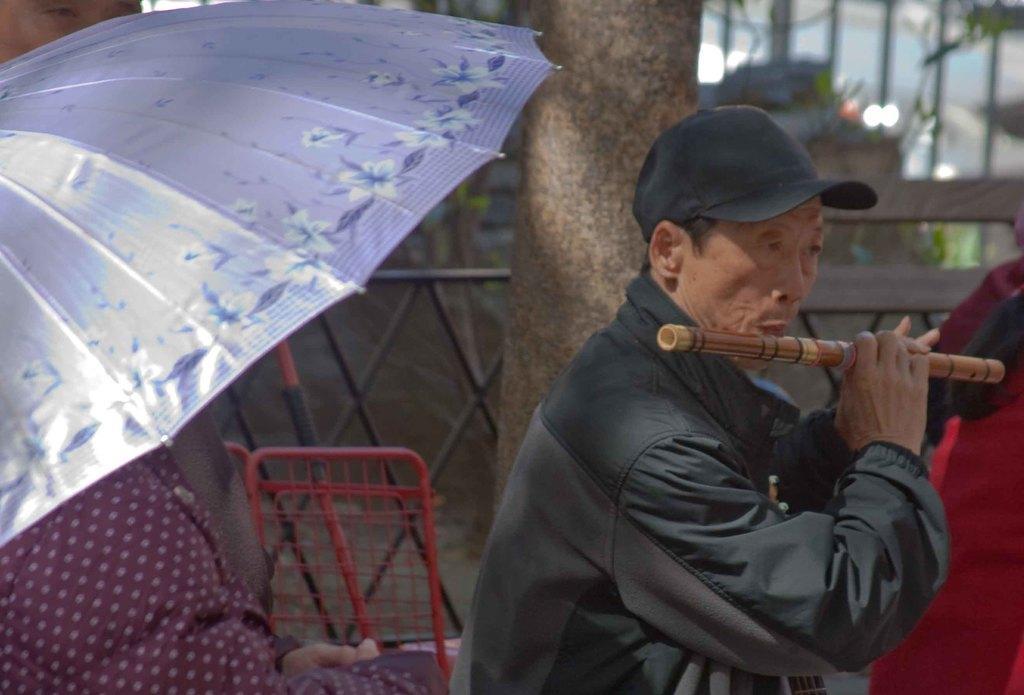Can you describe this image briefly? In this image the man is playing the flute and there is a umbrella. 